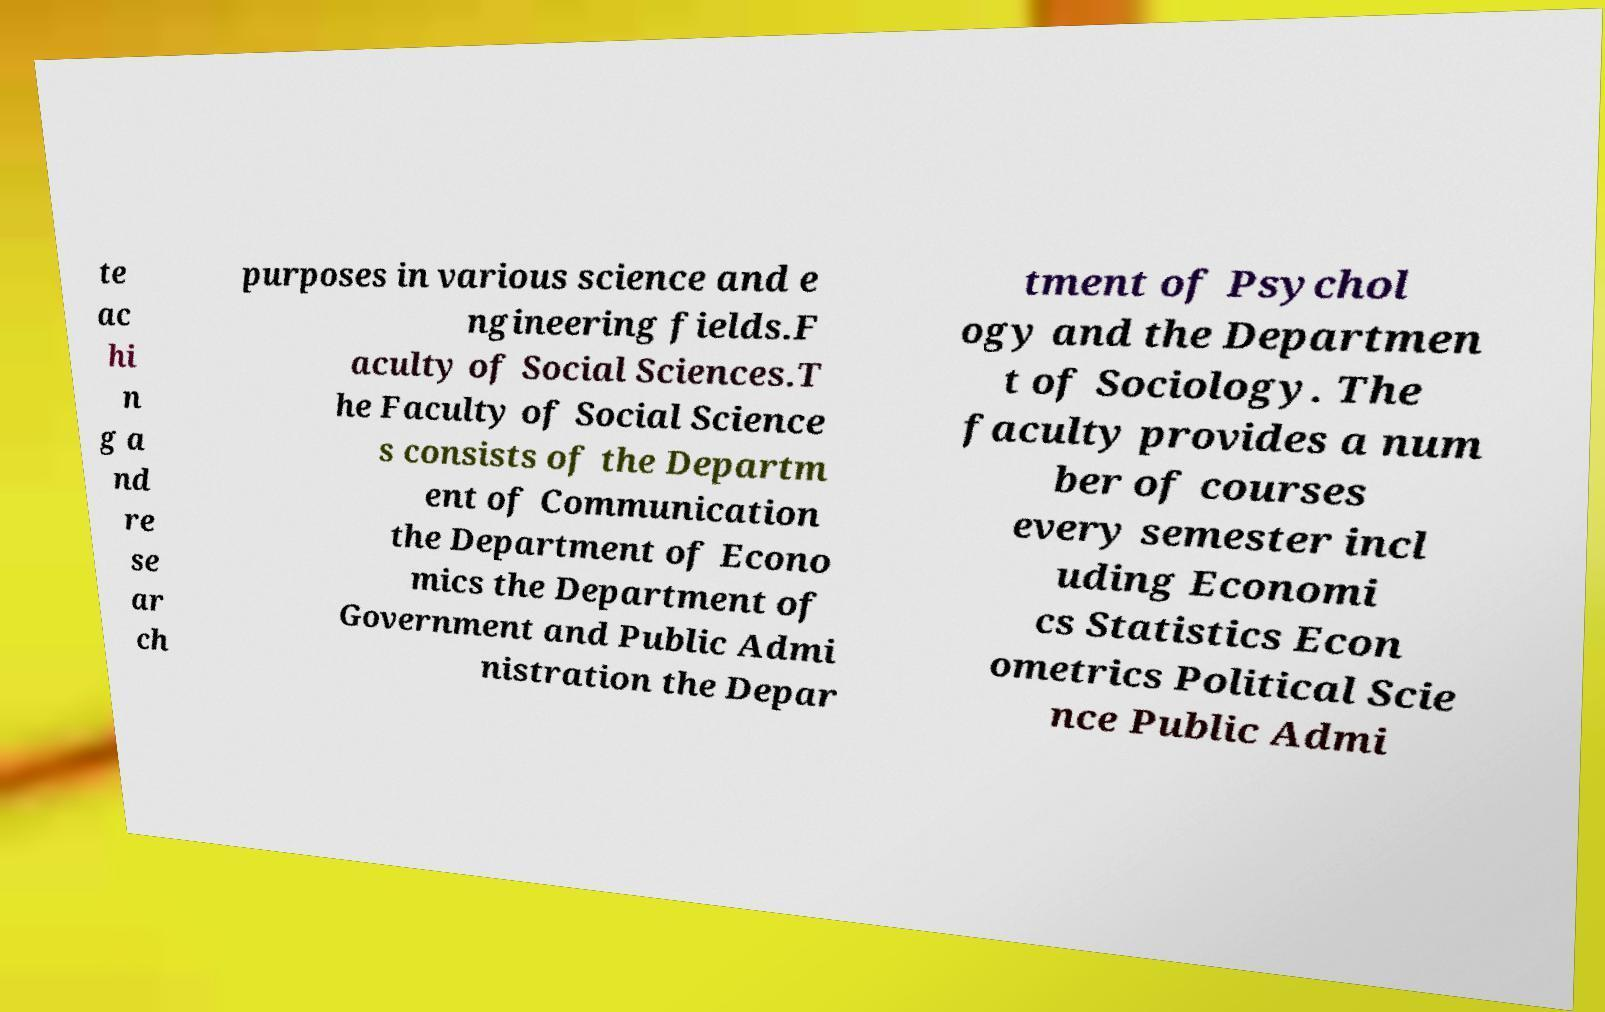What messages or text are displayed in this image? I need them in a readable, typed format. te ac hi n g a nd re se ar ch purposes in various science and e ngineering fields.F aculty of Social Sciences.T he Faculty of Social Science s consists of the Departm ent of Communication the Department of Econo mics the Department of Government and Public Admi nistration the Depar tment of Psychol ogy and the Departmen t of Sociology. The faculty provides a num ber of courses every semester incl uding Economi cs Statistics Econ ometrics Political Scie nce Public Admi 